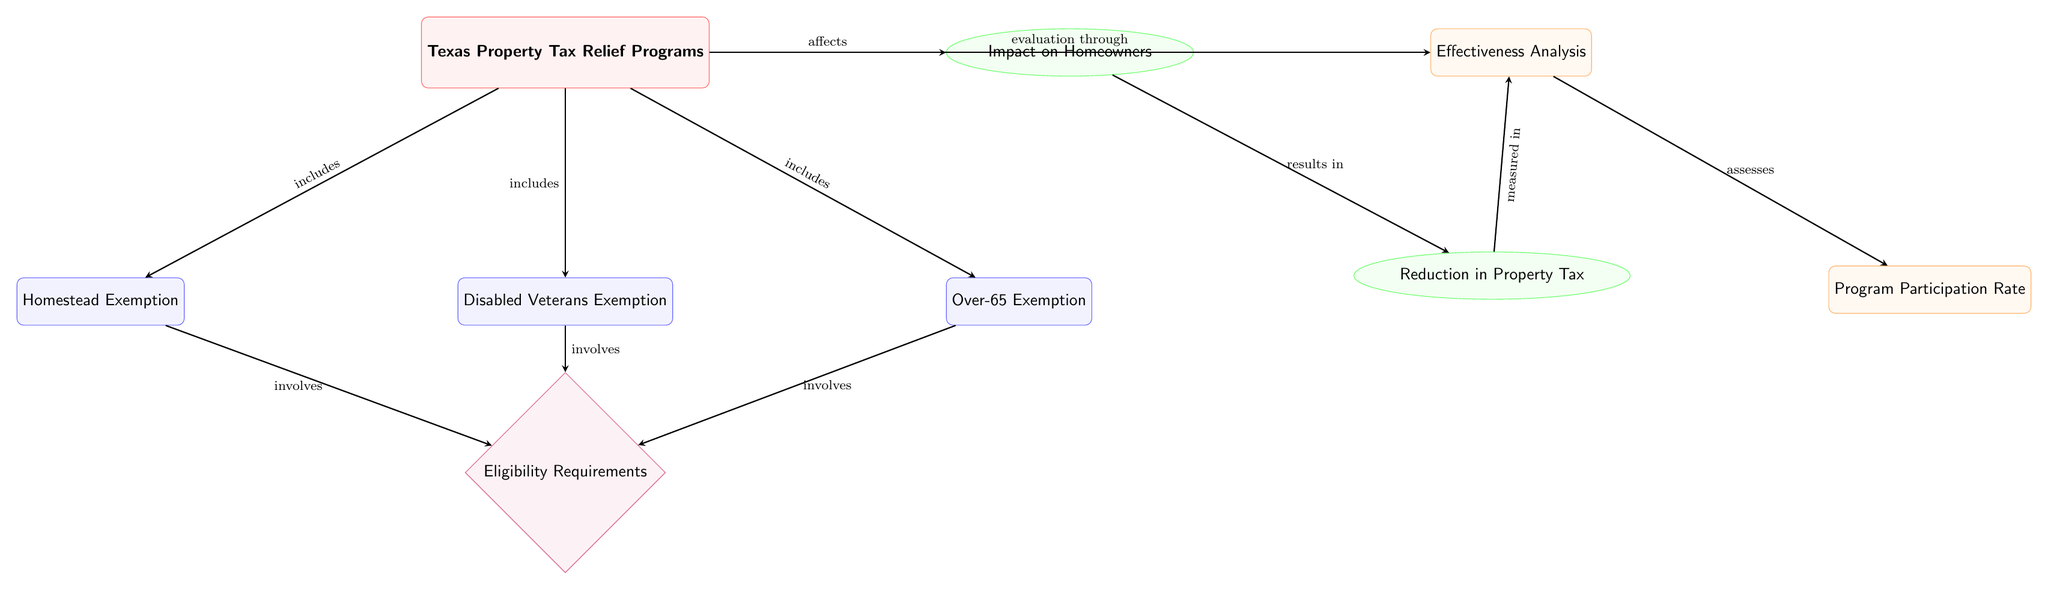What are the three property tax relief programs included in the diagram? The diagram lists three programs: Homestead Exemption, Disabled Veterans Exemption, and Over-65 Exemption. These programs are directly connected to the main node labeled 'Texas Property Tax Relief Programs'.
Answer: Homestead Exemption, Disabled Veterans Exemption, Over-65 Exemption What does the 'Impact on Homeowners' node represent? This node, labeled 'Impact on Homeowners', is connected to the main program node and indicates an outcome of the property tax relief programs. It demonstrates that these programs affect homeowners.
Answer: Impact on Homeowners Which node involves eligibility requirements? The 'Eligibility Requirements' node is shown as a diamond shape and is connected to all three program nodes (Homestead Exemption, Disabled Veterans Exemption, Over-65 Exemption), indicating that they each involve eligibility criteria.
Answer: Eligibility Requirements What is assessed in the 'Effectiveness Analysis'? The 'Effectiveness Analysis' node has an outgoing arrow to 'Program Participation Rate', indicating that the effect of the tax relief programs is being evaluated through the participation rate of homeowners in these programs.
Answer: Program Participation Rate How many main types of nodes are represented in the diagram? The diagram presents four main types of nodes: main, program, impact, criteria, and analysis. By counting the distinct styles of nodes utilized, there are five distinct types total in the diagram.
Answer: Five What relationship exists between the 'Reduction in Property Tax' and 'Effectiveness Analysis'? The diagram indicates that 'Reduction in Property Tax' is measured in effectiveness analysis, as shown by the arrow moving from 'Reduction in Property Tax' to 'Effectiveness Analysis', which indicates that the reduction is evaluated as part of the analysis process.
Answer: Measured in What type of diagram is this? The diagram is a Textbook Diagram, structured to represent and evaluate the relationships and flow between different components related to tax relief programs. It clearly illustrates the hierarchy and links among various elements.
Answer: Textbook Diagram What connects 'Texas Property Tax Relief Programs' to 'Impact on Homeowners'? The arrow labeled 'affects' connects 'Texas Property Tax Relief Programs' directly to 'Impact on Homeowners', indicating that the relief programs have a direct effect on the financial situations of homeowners.
Answer: Affects Which node does the arrow from 'Reduction in Property Tax' lead to? The arrow from 'Reduction in Property Tax' directly leads to 'Effectiveness Analysis', which indicates that the reduction in tax is an important metric being assessed in the analysis.
Answer: Effectiveness Analysis 